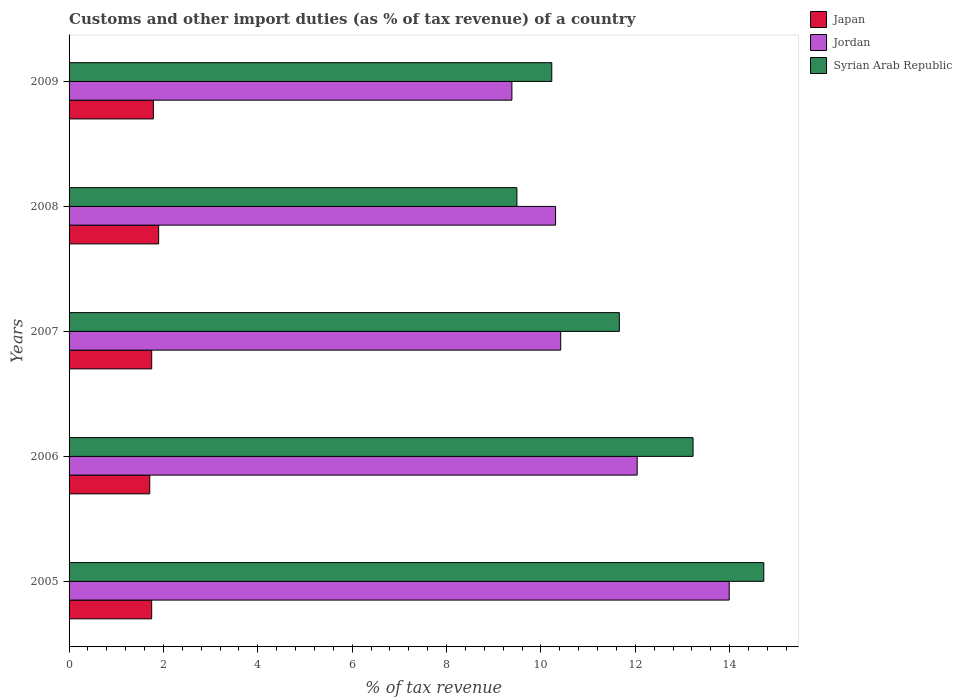How many different coloured bars are there?
Ensure brevity in your answer.  3. Are the number of bars per tick equal to the number of legend labels?
Ensure brevity in your answer.  Yes. Are the number of bars on each tick of the Y-axis equal?
Provide a succinct answer. Yes. How many bars are there on the 4th tick from the top?
Your answer should be very brief. 3. How many bars are there on the 5th tick from the bottom?
Make the answer very short. 3. What is the percentage of tax revenue from customs in Jordan in 2009?
Your response must be concise. 9.39. Across all years, what is the maximum percentage of tax revenue from customs in Syrian Arab Republic?
Offer a very short reply. 14.72. Across all years, what is the minimum percentage of tax revenue from customs in Jordan?
Provide a succinct answer. 9.39. In which year was the percentage of tax revenue from customs in Jordan minimum?
Make the answer very short. 2009. What is the total percentage of tax revenue from customs in Japan in the graph?
Ensure brevity in your answer.  8.9. What is the difference between the percentage of tax revenue from customs in Jordan in 2008 and that in 2009?
Provide a succinct answer. 0.93. What is the difference between the percentage of tax revenue from customs in Syrian Arab Republic in 2006 and the percentage of tax revenue from customs in Japan in 2009?
Ensure brevity in your answer.  11.44. What is the average percentage of tax revenue from customs in Japan per year?
Your answer should be very brief. 1.78. In the year 2005, what is the difference between the percentage of tax revenue from customs in Syrian Arab Republic and percentage of tax revenue from customs in Jordan?
Offer a terse response. 0.73. In how many years, is the percentage of tax revenue from customs in Syrian Arab Republic greater than 7.2 %?
Offer a terse response. 5. What is the ratio of the percentage of tax revenue from customs in Syrian Arab Republic in 2005 to that in 2006?
Give a very brief answer. 1.11. Is the percentage of tax revenue from customs in Jordan in 2007 less than that in 2009?
Give a very brief answer. No. Is the difference between the percentage of tax revenue from customs in Syrian Arab Republic in 2007 and 2008 greater than the difference between the percentage of tax revenue from customs in Jordan in 2007 and 2008?
Provide a short and direct response. Yes. What is the difference between the highest and the second highest percentage of tax revenue from customs in Syrian Arab Republic?
Provide a succinct answer. 1.5. What is the difference between the highest and the lowest percentage of tax revenue from customs in Jordan?
Keep it short and to the point. 4.61. Is the sum of the percentage of tax revenue from customs in Jordan in 2005 and 2008 greater than the maximum percentage of tax revenue from customs in Syrian Arab Republic across all years?
Offer a terse response. Yes. What does the 2nd bar from the top in 2009 represents?
Your answer should be very brief. Jordan. What does the 3rd bar from the bottom in 2007 represents?
Your answer should be compact. Syrian Arab Republic. How many bars are there?
Your answer should be very brief. 15. How many years are there in the graph?
Provide a succinct answer. 5. What is the difference between two consecutive major ticks on the X-axis?
Your response must be concise. 2. Are the values on the major ticks of X-axis written in scientific E-notation?
Ensure brevity in your answer.  No. Does the graph contain grids?
Offer a terse response. No. How many legend labels are there?
Ensure brevity in your answer.  3. How are the legend labels stacked?
Ensure brevity in your answer.  Vertical. What is the title of the graph?
Offer a very short reply. Customs and other import duties (as % of tax revenue) of a country. What is the label or title of the X-axis?
Provide a short and direct response. % of tax revenue. What is the label or title of the Y-axis?
Your response must be concise. Years. What is the % of tax revenue in Japan in 2005?
Make the answer very short. 1.75. What is the % of tax revenue of Jordan in 2005?
Make the answer very short. 13.99. What is the % of tax revenue in Syrian Arab Republic in 2005?
Ensure brevity in your answer.  14.72. What is the % of tax revenue of Japan in 2006?
Make the answer very short. 1.71. What is the % of tax revenue of Jordan in 2006?
Offer a very short reply. 12.04. What is the % of tax revenue in Syrian Arab Republic in 2006?
Offer a terse response. 13.22. What is the % of tax revenue in Japan in 2007?
Provide a succinct answer. 1.75. What is the % of tax revenue in Jordan in 2007?
Make the answer very short. 10.42. What is the % of tax revenue in Syrian Arab Republic in 2007?
Provide a succinct answer. 11.66. What is the % of tax revenue of Japan in 2008?
Your answer should be very brief. 1.9. What is the % of tax revenue in Jordan in 2008?
Ensure brevity in your answer.  10.31. What is the % of tax revenue in Syrian Arab Republic in 2008?
Provide a succinct answer. 9.49. What is the % of tax revenue of Japan in 2009?
Your answer should be compact. 1.79. What is the % of tax revenue in Jordan in 2009?
Your answer should be very brief. 9.39. What is the % of tax revenue in Syrian Arab Republic in 2009?
Make the answer very short. 10.23. Across all years, what is the maximum % of tax revenue of Japan?
Your answer should be very brief. 1.9. Across all years, what is the maximum % of tax revenue in Jordan?
Provide a succinct answer. 13.99. Across all years, what is the maximum % of tax revenue of Syrian Arab Republic?
Offer a terse response. 14.72. Across all years, what is the minimum % of tax revenue in Japan?
Your response must be concise. 1.71. Across all years, what is the minimum % of tax revenue in Jordan?
Provide a succinct answer. 9.39. Across all years, what is the minimum % of tax revenue in Syrian Arab Republic?
Provide a succinct answer. 9.49. What is the total % of tax revenue of Japan in the graph?
Offer a very short reply. 8.9. What is the total % of tax revenue of Jordan in the graph?
Your answer should be very brief. 56.15. What is the total % of tax revenue in Syrian Arab Republic in the graph?
Keep it short and to the point. 59.33. What is the difference between the % of tax revenue of Japan in 2005 and that in 2006?
Offer a terse response. 0.04. What is the difference between the % of tax revenue in Jordan in 2005 and that in 2006?
Offer a terse response. 1.95. What is the difference between the % of tax revenue in Syrian Arab Republic in 2005 and that in 2006?
Keep it short and to the point. 1.5. What is the difference between the % of tax revenue of Japan in 2005 and that in 2007?
Offer a very short reply. -0. What is the difference between the % of tax revenue of Jordan in 2005 and that in 2007?
Your response must be concise. 3.57. What is the difference between the % of tax revenue in Syrian Arab Republic in 2005 and that in 2007?
Offer a terse response. 3.06. What is the difference between the % of tax revenue of Japan in 2005 and that in 2008?
Offer a terse response. -0.15. What is the difference between the % of tax revenue in Jordan in 2005 and that in 2008?
Make the answer very short. 3.68. What is the difference between the % of tax revenue in Syrian Arab Republic in 2005 and that in 2008?
Offer a very short reply. 5.23. What is the difference between the % of tax revenue in Japan in 2005 and that in 2009?
Your response must be concise. -0.04. What is the difference between the % of tax revenue in Jordan in 2005 and that in 2009?
Your answer should be compact. 4.61. What is the difference between the % of tax revenue in Syrian Arab Republic in 2005 and that in 2009?
Make the answer very short. 4.49. What is the difference between the % of tax revenue of Japan in 2006 and that in 2007?
Offer a terse response. -0.04. What is the difference between the % of tax revenue in Jordan in 2006 and that in 2007?
Your answer should be compact. 1.62. What is the difference between the % of tax revenue of Syrian Arab Republic in 2006 and that in 2007?
Make the answer very short. 1.56. What is the difference between the % of tax revenue in Japan in 2006 and that in 2008?
Provide a short and direct response. -0.19. What is the difference between the % of tax revenue of Jordan in 2006 and that in 2008?
Your answer should be very brief. 1.73. What is the difference between the % of tax revenue of Syrian Arab Republic in 2006 and that in 2008?
Your response must be concise. 3.73. What is the difference between the % of tax revenue in Japan in 2006 and that in 2009?
Offer a very short reply. -0.08. What is the difference between the % of tax revenue in Jordan in 2006 and that in 2009?
Your response must be concise. 2.66. What is the difference between the % of tax revenue of Syrian Arab Republic in 2006 and that in 2009?
Keep it short and to the point. 2.99. What is the difference between the % of tax revenue of Japan in 2007 and that in 2008?
Offer a very short reply. -0.15. What is the difference between the % of tax revenue of Jordan in 2007 and that in 2008?
Provide a short and direct response. 0.11. What is the difference between the % of tax revenue in Syrian Arab Republic in 2007 and that in 2008?
Ensure brevity in your answer.  2.17. What is the difference between the % of tax revenue of Japan in 2007 and that in 2009?
Offer a very short reply. -0.04. What is the difference between the % of tax revenue of Jordan in 2007 and that in 2009?
Your answer should be very brief. 1.03. What is the difference between the % of tax revenue in Syrian Arab Republic in 2007 and that in 2009?
Keep it short and to the point. 1.43. What is the difference between the % of tax revenue of Japan in 2008 and that in 2009?
Your answer should be very brief. 0.11. What is the difference between the % of tax revenue of Jordan in 2008 and that in 2009?
Your answer should be very brief. 0.93. What is the difference between the % of tax revenue of Syrian Arab Republic in 2008 and that in 2009?
Your response must be concise. -0.74. What is the difference between the % of tax revenue of Japan in 2005 and the % of tax revenue of Jordan in 2006?
Provide a short and direct response. -10.29. What is the difference between the % of tax revenue in Japan in 2005 and the % of tax revenue in Syrian Arab Republic in 2006?
Provide a short and direct response. -11.47. What is the difference between the % of tax revenue of Jordan in 2005 and the % of tax revenue of Syrian Arab Republic in 2006?
Your response must be concise. 0.77. What is the difference between the % of tax revenue in Japan in 2005 and the % of tax revenue in Jordan in 2007?
Provide a succinct answer. -8.67. What is the difference between the % of tax revenue of Japan in 2005 and the % of tax revenue of Syrian Arab Republic in 2007?
Provide a succinct answer. -9.91. What is the difference between the % of tax revenue in Jordan in 2005 and the % of tax revenue in Syrian Arab Republic in 2007?
Your answer should be very brief. 2.33. What is the difference between the % of tax revenue in Japan in 2005 and the % of tax revenue in Jordan in 2008?
Provide a succinct answer. -8.56. What is the difference between the % of tax revenue of Japan in 2005 and the % of tax revenue of Syrian Arab Republic in 2008?
Your answer should be compact. -7.74. What is the difference between the % of tax revenue in Jordan in 2005 and the % of tax revenue in Syrian Arab Republic in 2008?
Ensure brevity in your answer.  4.5. What is the difference between the % of tax revenue in Japan in 2005 and the % of tax revenue in Jordan in 2009?
Your answer should be compact. -7.63. What is the difference between the % of tax revenue of Japan in 2005 and the % of tax revenue of Syrian Arab Republic in 2009?
Keep it short and to the point. -8.48. What is the difference between the % of tax revenue in Jordan in 2005 and the % of tax revenue in Syrian Arab Republic in 2009?
Your answer should be compact. 3.76. What is the difference between the % of tax revenue in Japan in 2006 and the % of tax revenue in Jordan in 2007?
Your answer should be very brief. -8.71. What is the difference between the % of tax revenue of Japan in 2006 and the % of tax revenue of Syrian Arab Republic in 2007?
Keep it short and to the point. -9.95. What is the difference between the % of tax revenue in Jordan in 2006 and the % of tax revenue in Syrian Arab Republic in 2007?
Offer a terse response. 0.38. What is the difference between the % of tax revenue of Japan in 2006 and the % of tax revenue of Jordan in 2008?
Your answer should be compact. -8.6. What is the difference between the % of tax revenue in Japan in 2006 and the % of tax revenue in Syrian Arab Republic in 2008?
Make the answer very short. -7.78. What is the difference between the % of tax revenue of Jordan in 2006 and the % of tax revenue of Syrian Arab Republic in 2008?
Offer a terse response. 2.55. What is the difference between the % of tax revenue in Japan in 2006 and the % of tax revenue in Jordan in 2009?
Ensure brevity in your answer.  -7.68. What is the difference between the % of tax revenue in Japan in 2006 and the % of tax revenue in Syrian Arab Republic in 2009?
Offer a terse response. -8.52. What is the difference between the % of tax revenue in Jordan in 2006 and the % of tax revenue in Syrian Arab Republic in 2009?
Your response must be concise. 1.81. What is the difference between the % of tax revenue in Japan in 2007 and the % of tax revenue in Jordan in 2008?
Offer a terse response. -8.56. What is the difference between the % of tax revenue in Japan in 2007 and the % of tax revenue in Syrian Arab Republic in 2008?
Keep it short and to the point. -7.74. What is the difference between the % of tax revenue in Jordan in 2007 and the % of tax revenue in Syrian Arab Republic in 2008?
Your response must be concise. 0.93. What is the difference between the % of tax revenue in Japan in 2007 and the % of tax revenue in Jordan in 2009?
Your response must be concise. -7.63. What is the difference between the % of tax revenue in Japan in 2007 and the % of tax revenue in Syrian Arab Republic in 2009?
Make the answer very short. -8.48. What is the difference between the % of tax revenue in Jordan in 2007 and the % of tax revenue in Syrian Arab Republic in 2009?
Provide a succinct answer. 0.19. What is the difference between the % of tax revenue of Japan in 2008 and the % of tax revenue of Jordan in 2009?
Make the answer very short. -7.49. What is the difference between the % of tax revenue of Japan in 2008 and the % of tax revenue of Syrian Arab Republic in 2009?
Give a very brief answer. -8.33. What is the difference between the % of tax revenue of Jordan in 2008 and the % of tax revenue of Syrian Arab Republic in 2009?
Offer a terse response. 0.08. What is the average % of tax revenue in Japan per year?
Ensure brevity in your answer.  1.78. What is the average % of tax revenue of Jordan per year?
Provide a succinct answer. 11.23. What is the average % of tax revenue in Syrian Arab Republic per year?
Your answer should be compact. 11.87. In the year 2005, what is the difference between the % of tax revenue in Japan and % of tax revenue in Jordan?
Keep it short and to the point. -12.24. In the year 2005, what is the difference between the % of tax revenue in Japan and % of tax revenue in Syrian Arab Republic?
Offer a terse response. -12.97. In the year 2005, what is the difference between the % of tax revenue in Jordan and % of tax revenue in Syrian Arab Republic?
Your answer should be compact. -0.73. In the year 2006, what is the difference between the % of tax revenue in Japan and % of tax revenue in Jordan?
Your answer should be very brief. -10.33. In the year 2006, what is the difference between the % of tax revenue in Japan and % of tax revenue in Syrian Arab Republic?
Make the answer very short. -11.51. In the year 2006, what is the difference between the % of tax revenue of Jordan and % of tax revenue of Syrian Arab Republic?
Offer a terse response. -1.18. In the year 2007, what is the difference between the % of tax revenue in Japan and % of tax revenue in Jordan?
Make the answer very short. -8.67. In the year 2007, what is the difference between the % of tax revenue in Japan and % of tax revenue in Syrian Arab Republic?
Give a very brief answer. -9.91. In the year 2007, what is the difference between the % of tax revenue in Jordan and % of tax revenue in Syrian Arab Republic?
Offer a terse response. -1.24. In the year 2008, what is the difference between the % of tax revenue in Japan and % of tax revenue in Jordan?
Provide a succinct answer. -8.41. In the year 2008, what is the difference between the % of tax revenue of Japan and % of tax revenue of Syrian Arab Republic?
Your response must be concise. -7.59. In the year 2008, what is the difference between the % of tax revenue of Jordan and % of tax revenue of Syrian Arab Republic?
Offer a terse response. 0.82. In the year 2009, what is the difference between the % of tax revenue in Japan and % of tax revenue in Jordan?
Provide a succinct answer. -7.6. In the year 2009, what is the difference between the % of tax revenue in Japan and % of tax revenue in Syrian Arab Republic?
Give a very brief answer. -8.44. In the year 2009, what is the difference between the % of tax revenue in Jordan and % of tax revenue in Syrian Arab Republic?
Your answer should be very brief. -0.84. What is the ratio of the % of tax revenue of Japan in 2005 to that in 2006?
Give a very brief answer. 1.02. What is the ratio of the % of tax revenue in Jordan in 2005 to that in 2006?
Provide a short and direct response. 1.16. What is the ratio of the % of tax revenue of Syrian Arab Republic in 2005 to that in 2006?
Your response must be concise. 1.11. What is the ratio of the % of tax revenue in Japan in 2005 to that in 2007?
Your answer should be compact. 1. What is the ratio of the % of tax revenue in Jordan in 2005 to that in 2007?
Make the answer very short. 1.34. What is the ratio of the % of tax revenue of Syrian Arab Republic in 2005 to that in 2007?
Make the answer very short. 1.26. What is the ratio of the % of tax revenue in Japan in 2005 to that in 2008?
Keep it short and to the point. 0.92. What is the ratio of the % of tax revenue in Jordan in 2005 to that in 2008?
Your answer should be compact. 1.36. What is the ratio of the % of tax revenue of Syrian Arab Republic in 2005 to that in 2008?
Your response must be concise. 1.55. What is the ratio of the % of tax revenue in Jordan in 2005 to that in 2009?
Provide a short and direct response. 1.49. What is the ratio of the % of tax revenue of Syrian Arab Republic in 2005 to that in 2009?
Your response must be concise. 1.44. What is the ratio of the % of tax revenue in Japan in 2006 to that in 2007?
Make the answer very short. 0.98. What is the ratio of the % of tax revenue in Jordan in 2006 to that in 2007?
Keep it short and to the point. 1.16. What is the ratio of the % of tax revenue of Syrian Arab Republic in 2006 to that in 2007?
Provide a short and direct response. 1.13. What is the ratio of the % of tax revenue of Japan in 2006 to that in 2008?
Keep it short and to the point. 0.9. What is the ratio of the % of tax revenue in Jordan in 2006 to that in 2008?
Keep it short and to the point. 1.17. What is the ratio of the % of tax revenue in Syrian Arab Republic in 2006 to that in 2008?
Provide a short and direct response. 1.39. What is the ratio of the % of tax revenue of Japan in 2006 to that in 2009?
Your response must be concise. 0.96. What is the ratio of the % of tax revenue in Jordan in 2006 to that in 2009?
Offer a very short reply. 1.28. What is the ratio of the % of tax revenue of Syrian Arab Republic in 2006 to that in 2009?
Give a very brief answer. 1.29. What is the ratio of the % of tax revenue in Japan in 2007 to that in 2008?
Give a very brief answer. 0.92. What is the ratio of the % of tax revenue of Jordan in 2007 to that in 2008?
Provide a succinct answer. 1.01. What is the ratio of the % of tax revenue of Syrian Arab Republic in 2007 to that in 2008?
Your response must be concise. 1.23. What is the ratio of the % of tax revenue of Japan in 2007 to that in 2009?
Your answer should be very brief. 0.98. What is the ratio of the % of tax revenue of Jordan in 2007 to that in 2009?
Ensure brevity in your answer.  1.11. What is the ratio of the % of tax revenue in Syrian Arab Republic in 2007 to that in 2009?
Offer a very short reply. 1.14. What is the ratio of the % of tax revenue of Japan in 2008 to that in 2009?
Your response must be concise. 1.06. What is the ratio of the % of tax revenue of Jordan in 2008 to that in 2009?
Your answer should be compact. 1.1. What is the ratio of the % of tax revenue of Syrian Arab Republic in 2008 to that in 2009?
Keep it short and to the point. 0.93. What is the difference between the highest and the second highest % of tax revenue in Japan?
Provide a short and direct response. 0.11. What is the difference between the highest and the second highest % of tax revenue in Jordan?
Keep it short and to the point. 1.95. What is the difference between the highest and the second highest % of tax revenue in Syrian Arab Republic?
Offer a terse response. 1.5. What is the difference between the highest and the lowest % of tax revenue of Japan?
Give a very brief answer. 0.19. What is the difference between the highest and the lowest % of tax revenue in Jordan?
Your response must be concise. 4.61. What is the difference between the highest and the lowest % of tax revenue in Syrian Arab Republic?
Your response must be concise. 5.23. 